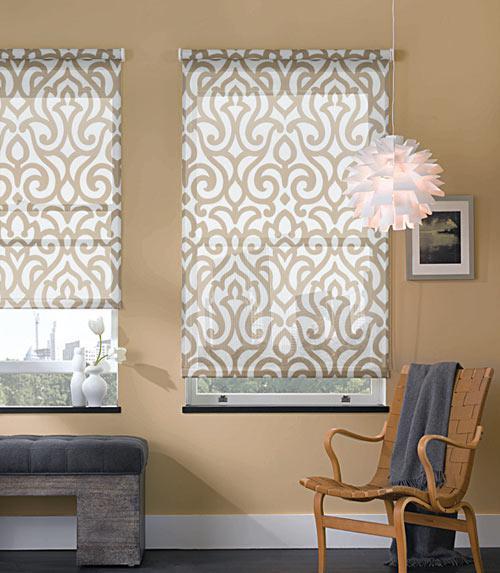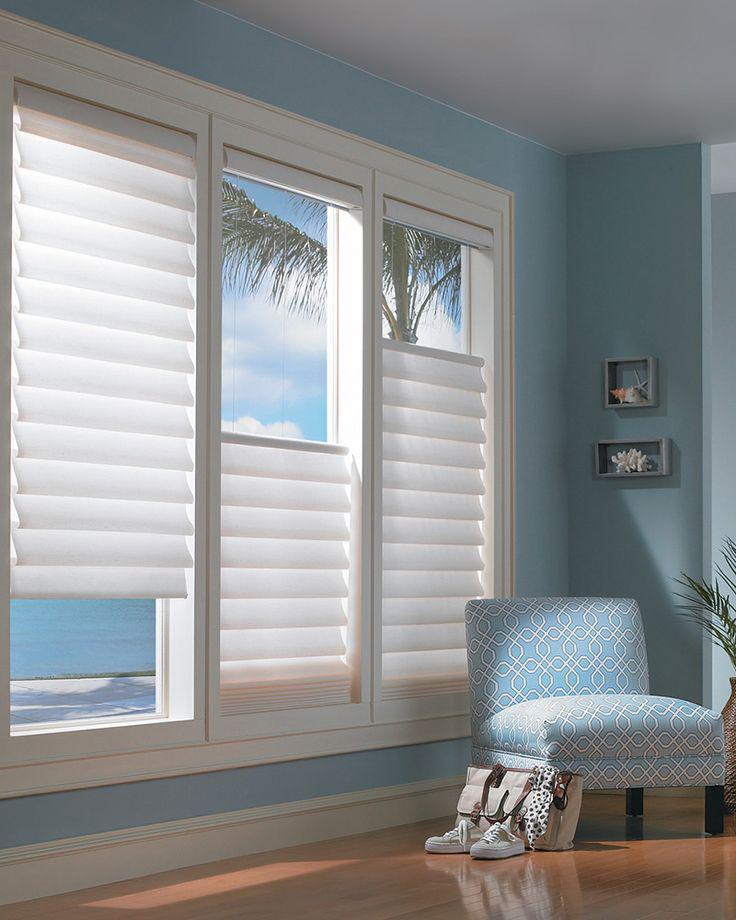The first image is the image on the left, the second image is the image on the right. Considering the images on both sides, is "In at least one image there are two blinds that are both open at different levels." valid? Answer yes or no. Yes. The first image is the image on the left, the second image is the image on the right. Examine the images to the left and right. Is the description "The left image shows a chair to the right of a window with a pattern-printed window shade." accurate? Answer yes or no. Yes. 